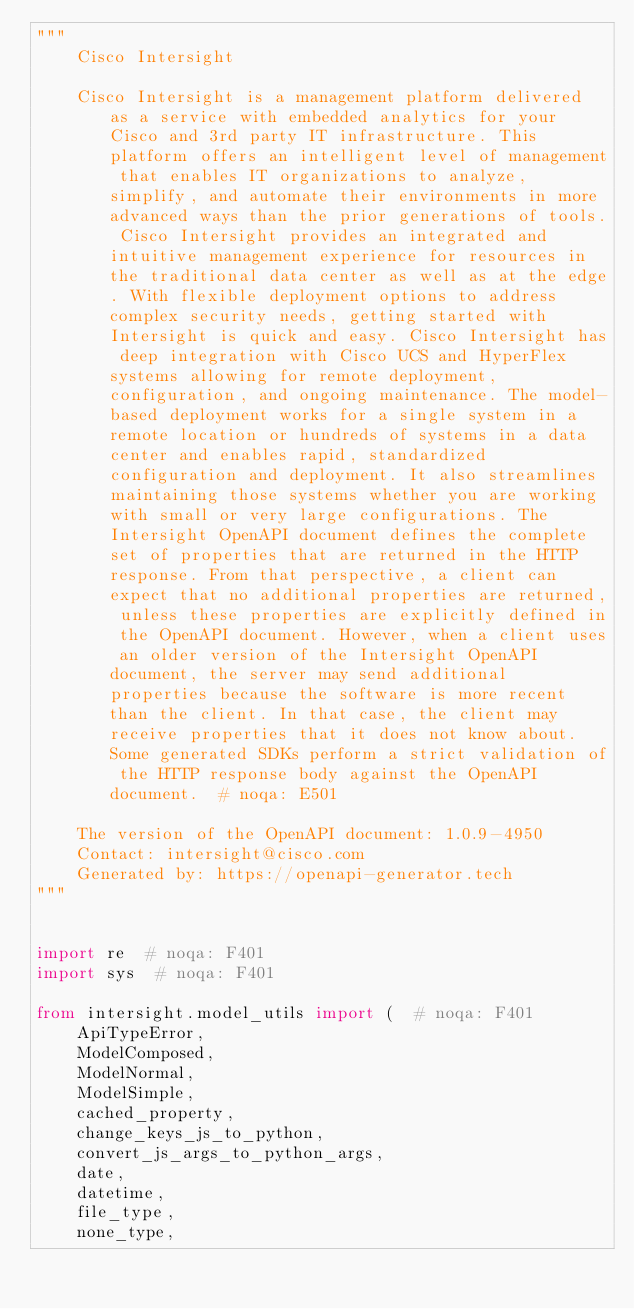Convert code to text. <code><loc_0><loc_0><loc_500><loc_500><_Python_>"""
    Cisco Intersight

    Cisco Intersight is a management platform delivered as a service with embedded analytics for your Cisco and 3rd party IT infrastructure. This platform offers an intelligent level of management that enables IT organizations to analyze, simplify, and automate their environments in more advanced ways than the prior generations of tools. Cisco Intersight provides an integrated and intuitive management experience for resources in the traditional data center as well as at the edge. With flexible deployment options to address complex security needs, getting started with Intersight is quick and easy. Cisco Intersight has deep integration with Cisco UCS and HyperFlex systems allowing for remote deployment, configuration, and ongoing maintenance. The model-based deployment works for a single system in a remote location or hundreds of systems in a data center and enables rapid, standardized configuration and deployment. It also streamlines maintaining those systems whether you are working with small or very large configurations. The Intersight OpenAPI document defines the complete set of properties that are returned in the HTTP response. From that perspective, a client can expect that no additional properties are returned, unless these properties are explicitly defined in the OpenAPI document. However, when a client uses an older version of the Intersight OpenAPI document, the server may send additional properties because the software is more recent than the client. In that case, the client may receive properties that it does not know about. Some generated SDKs perform a strict validation of the HTTP response body against the OpenAPI document.  # noqa: E501

    The version of the OpenAPI document: 1.0.9-4950
    Contact: intersight@cisco.com
    Generated by: https://openapi-generator.tech
"""


import re  # noqa: F401
import sys  # noqa: F401

from intersight.model_utils import (  # noqa: F401
    ApiTypeError,
    ModelComposed,
    ModelNormal,
    ModelSimple,
    cached_property,
    change_keys_js_to_python,
    convert_js_args_to_python_args,
    date,
    datetime,
    file_type,
    none_type,</code> 